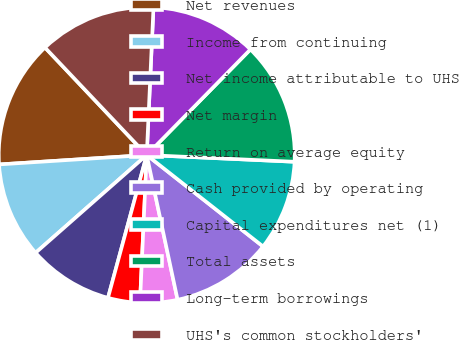Convert chart to OTSL. <chart><loc_0><loc_0><loc_500><loc_500><pie_chart><fcel>Net revenues<fcel>Income from continuing<fcel>Net income attributable to UHS<fcel>Net margin<fcel>Return on average equity<fcel>Cash provided by operating<fcel>Capital expenditures net (1)<fcel>Total assets<fcel>Long-term borrowings<fcel>UHS's common stockholders'<nl><fcel>13.95%<fcel>10.47%<fcel>9.3%<fcel>3.49%<fcel>4.07%<fcel>11.05%<fcel>9.88%<fcel>13.37%<fcel>11.63%<fcel>12.79%<nl></chart> 